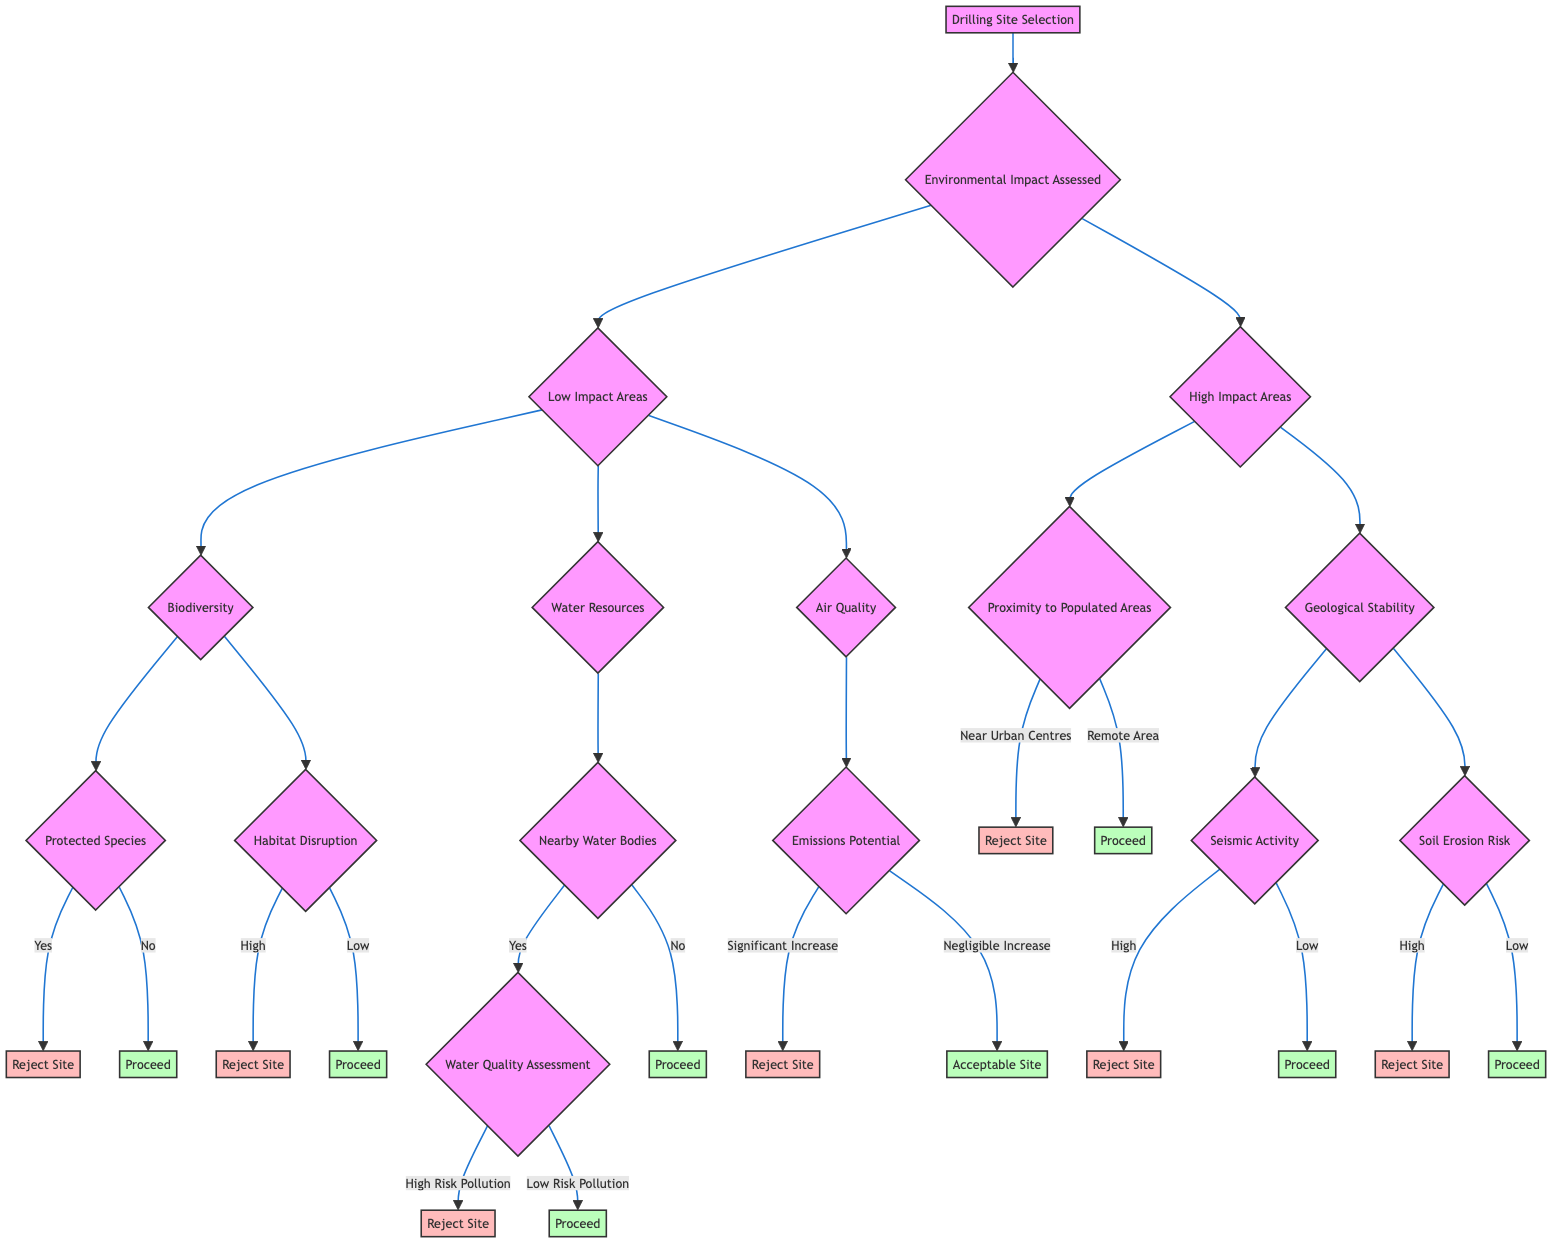What are the two main categories under Environmental Impact Assessed? The diagram clearly shows that the two main categories under Environmental Impact Assessed are Low Impact Areas and High Impact Areas. This can be seen directly after the Environmental Impact Assessed node.
Answer: Low Impact Areas, High Impact Areas What happens if Biodiversity's Protected Species criterion shows "Yes"? According to the decision tree, if the Protected Species criterion shows "Yes," the outcome is to Reject Site, as indicated directly in the flow from the Protected Species node.
Answer: Reject Site What is the action taken if there is High Risk Pollution in the Water Quality Assessment? The diagram states that if there is High Risk Pollution in the Water Quality Assessment, then the action taken is to Reject Site. This is a direct output from the Water Quality Assessment node.
Answer: Reject Site In High Impact Areas, what must be satisfied to proceed after checking the Proximity to Populated Areas? In High Impact Areas, if the Proximity to Populated Areas indicates "Remote Area," then the process can proceed to the next criterion, as shown in the flowchart from the Proximity to Populated Areas node.
Answer: Proceed to Next Criterion What are the two evaluations under Geological Stability? The diagram indicates that the two evaluations under Geological Stability are Seismic Activity and Soil Erosion Risk. These are both criteria that must be assessed before moving forward in High Impact Areas.
Answer: Seismic Activity, Soil Erosion Risk What is the flow from Emissions Potential if the outcome is Negligible Increase? If the outcome for Emissions Potential is Negligible Increase, the flow indicates that the site is considered Acceptable Site. This follows directly from the Emissions Potential node.
Answer: Acceptable Site In Low Impact Areas, if Habitat Disruption is Low, what is the next step? If Habitat Disruption is assessed as Low in Low Impact Areas, the next step is to Proceed to Next Criterion, as shown in the decision path of the diagram.
Answer: Proceed to Next Criterion How many rejection outcomes are there following the Biodiversity criteria? The diagram shows there are two rejection outcomes following the Biodiversity criteria: one from Protected Species (Yes) and one from Habitat Disruption (High). This can be counted directly from the decision nodes.
Answer: 2 